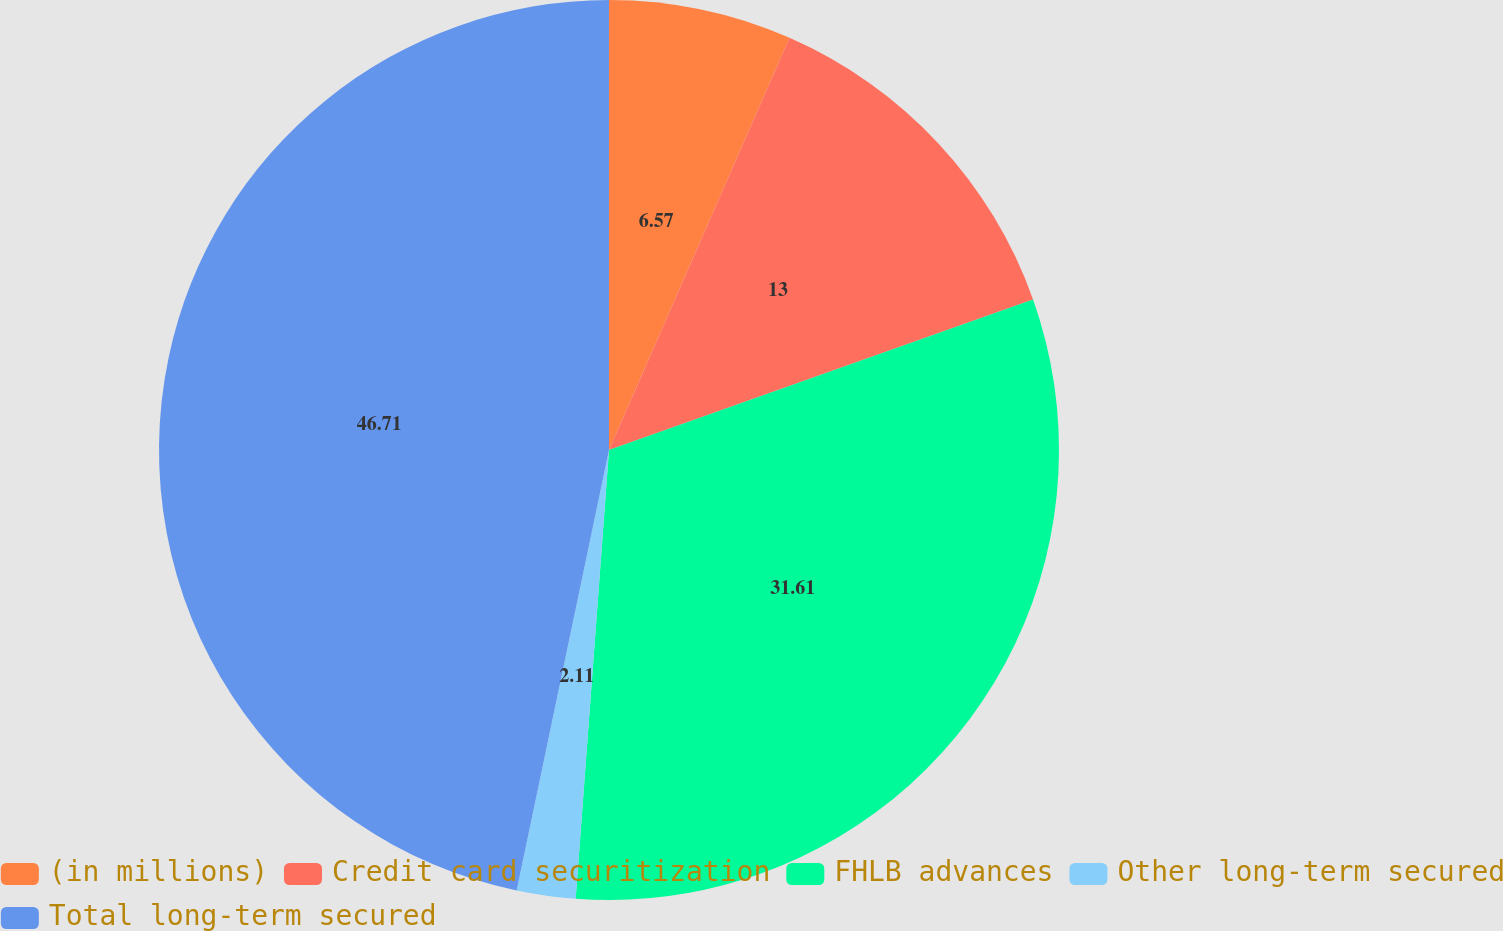<chart> <loc_0><loc_0><loc_500><loc_500><pie_chart><fcel>(in millions)<fcel>Credit card securitization<fcel>FHLB advances<fcel>Other long-term secured<fcel>Total long-term secured<nl><fcel>6.57%<fcel>13.0%<fcel>31.61%<fcel>2.11%<fcel>46.71%<nl></chart> 